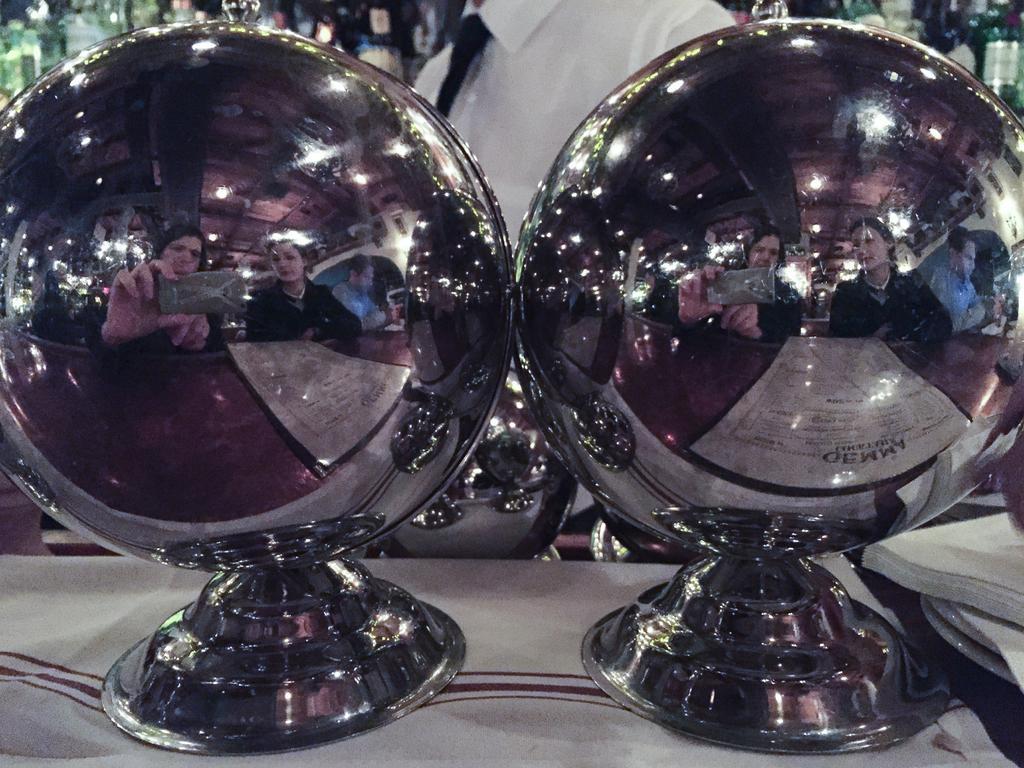Describe this image in one or two sentences. In this image there is a cloth towards the bottom of the image, there are two objects on the cloth, there is a man towards the top of the image, there is an object towards the top of the image, there is an object towards the right of the image, we can see the reflection of two women on the object, there is a reflection of a man, there is a reflection of a table, there is a paper on the table, there is reflection of lights on the object, there is a reflection of the roof. 